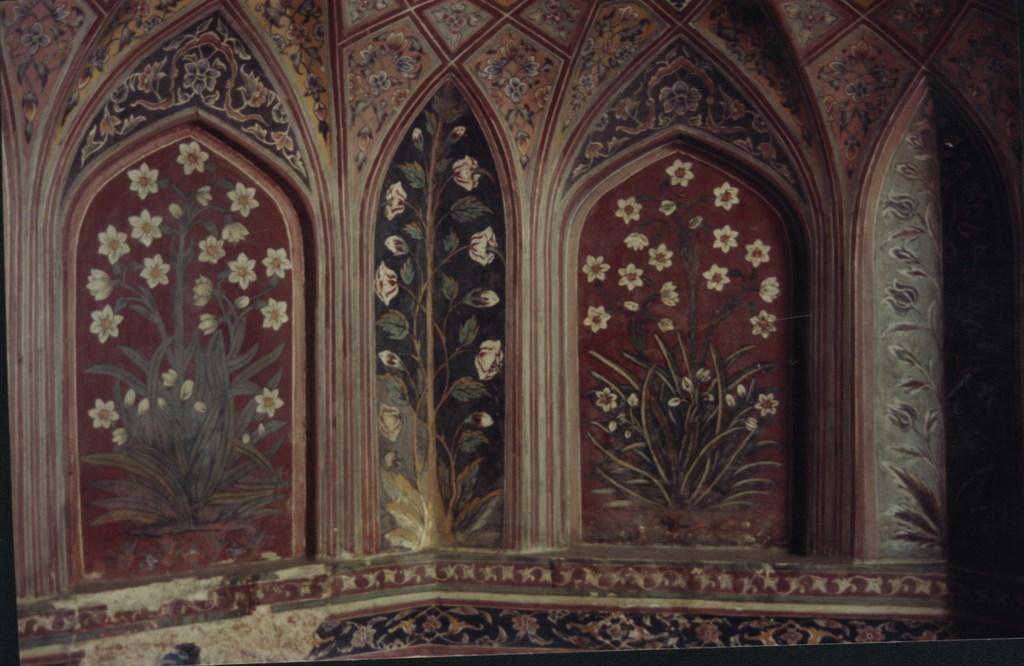What is the main subject of the image? There is a painting in the image. What is depicted in the painting? The painting depicts plants and flowers. Where is the painting located in the image? The painting is on a wall. What type of clouds can be seen in the painting? There are no clouds depicted in the painting; it features plants and flowers. Is there a cow present in the painting? No, there is no cow present in the painting; it depicts plants and flowers. 